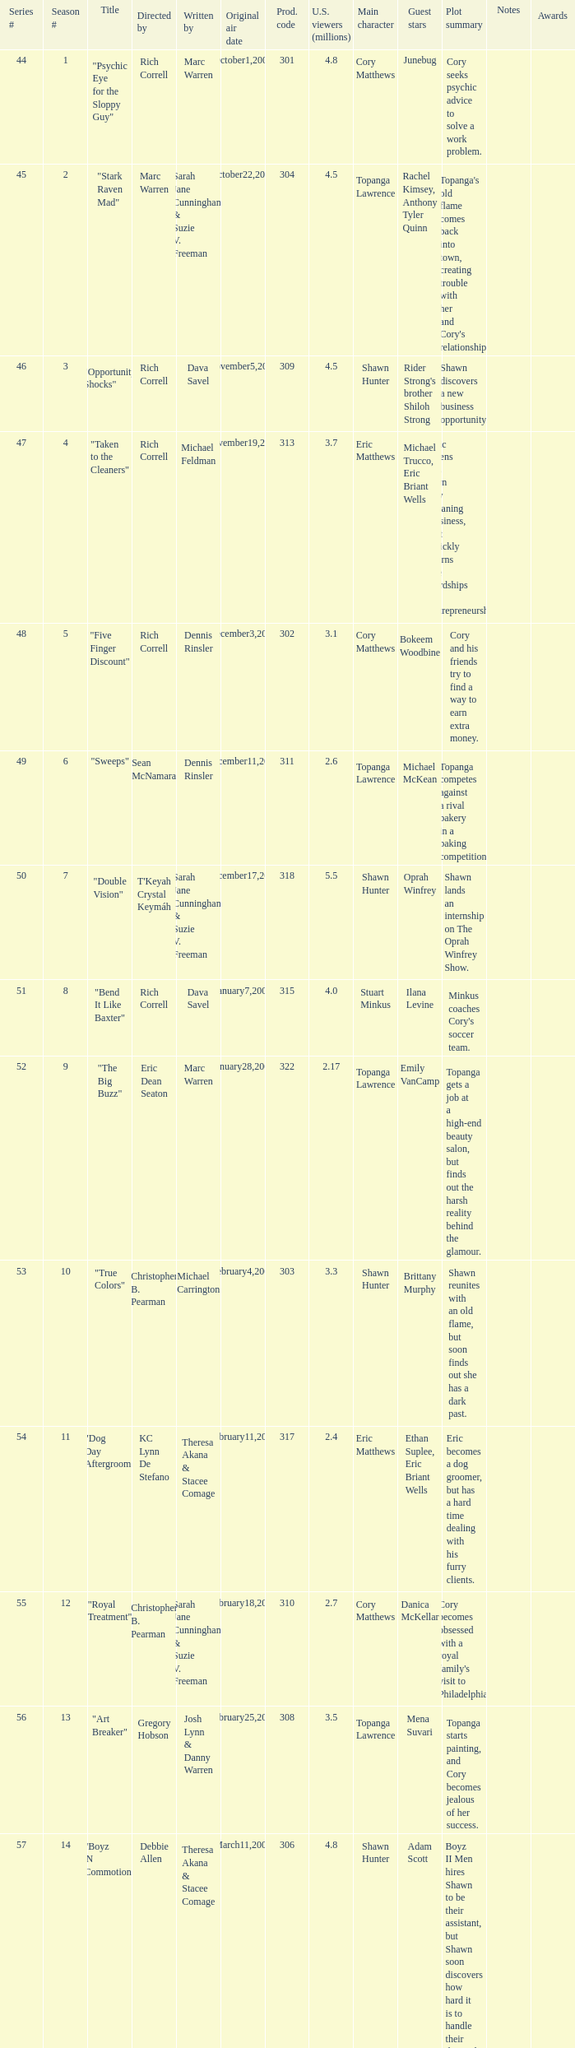What number episode in the season had a production code of 334? 32.0. 